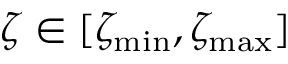<formula> <loc_0><loc_0><loc_500><loc_500>\zeta \in [ \zeta _ { \min } , \zeta _ { \max } ]</formula> 